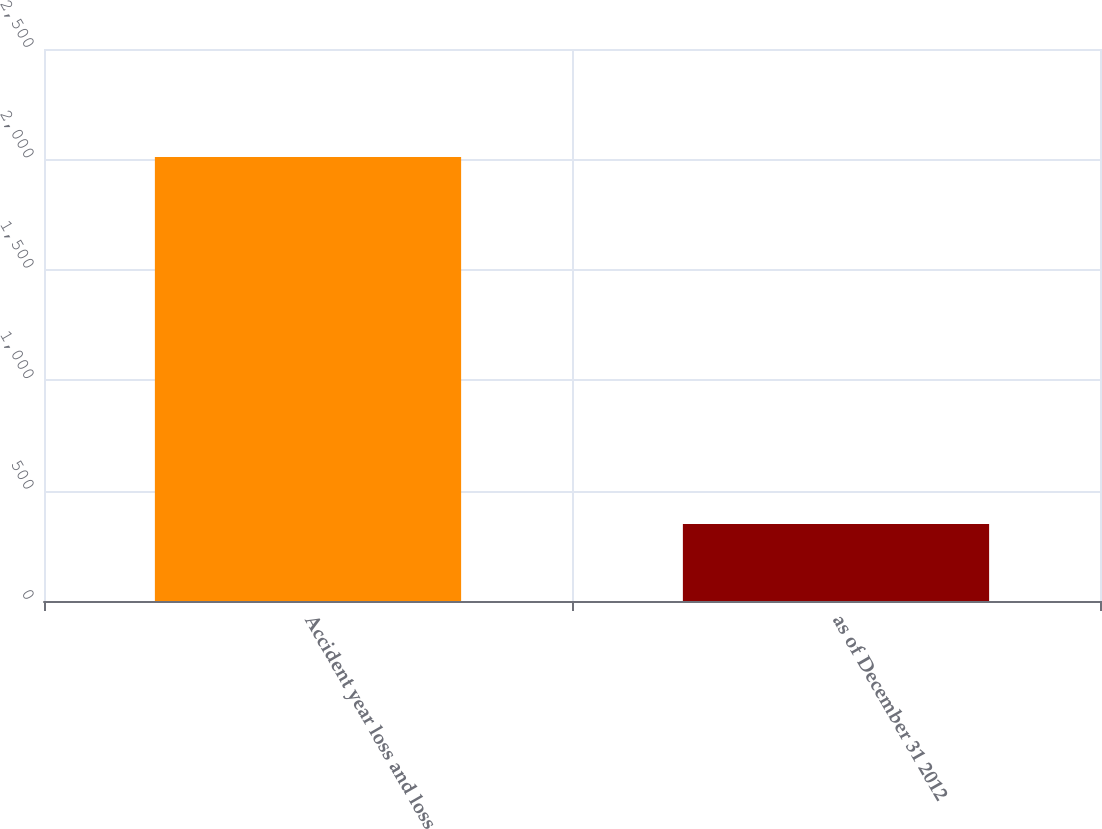Convert chart. <chart><loc_0><loc_0><loc_500><loc_500><bar_chart><fcel>Accident year loss and loss<fcel>as of December 31 2012<nl><fcel>2011<fcel>349<nl></chart> 